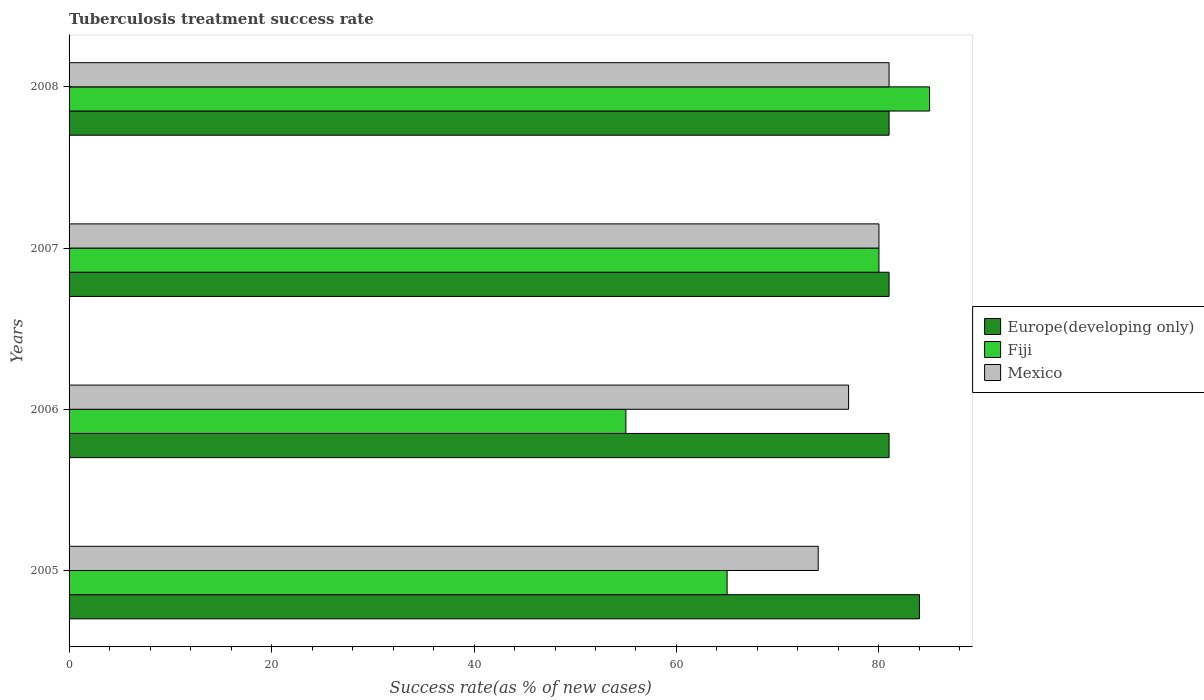How many bars are there on the 2nd tick from the bottom?
Your response must be concise. 3. What is the label of the 2nd group of bars from the top?
Offer a terse response. 2007. What is the tuberculosis treatment success rate in Fiji in 2006?
Ensure brevity in your answer.  55. Across all years, what is the maximum tuberculosis treatment success rate in Fiji?
Provide a short and direct response. 85. Across all years, what is the minimum tuberculosis treatment success rate in Mexico?
Offer a very short reply. 74. What is the total tuberculosis treatment success rate in Europe(developing only) in the graph?
Your answer should be very brief. 327. What is the difference between the tuberculosis treatment success rate in Fiji in 2005 and that in 2008?
Your response must be concise. -20. What is the average tuberculosis treatment success rate in Mexico per year?
Give a very brief answer. 78. In how many years, is the tuberculosis treatment success rate in Fiji greater than 64 %?
Offer a very short reply. 3. What is the ratio of the tuberculosis treatment success rate in Mexico in 2005 to that in 2008?
Give a very brief answer. 0.91. In how many years, is the tuberculosis treatment success rate in Fiji greater than the average tuberculosis treatment success rate in Fiji taken over all years?
Provide a succinct answer. 2. Is the sum of the tuberculosis treatment success rate in Mexico in 2007 and 2008 greater than the maximum tuberculosis treatment success rate in Europe(developing only) across all years?
Keep it short and to the point. Yes. What does the 2nd bar from the top in 2005 represents?
Offer a terse response. Fiji. Is it the case that in every year, the sum of the tuberculosis treatment success rate in Mexico and tuberculosis treatment success rate in Europe(developing only) is greater than the tuberculosis treatment success rate in Fiji?
Give a very brief answer. Yes. How many bars are there?
Provide a short and direct response. 12. Are the values on the major ticks of X-axis written in scientific E-notation?
Offer a very short reply. No. Where does the legend appear in the graph?
Provide a short and direct response. Center right. How are the legend labels stacked?
Your answer should be very brief. Vertical. What is the title of the graph?
Keep it short and to the point. Tuberculosis treatment success rate. What is the label or title of the X-axis?
Make the answer very short. Success rate(as % of new cases). What is the label or title of the Y-axis?
Your answer should be very brief. Years. What is the Success rate(as % of new cases) in Fiji in 2005?
Your answer should be very brief. 65. What is the Success rate(as % of new cases) in Mexico in 2005?
Ensure brevity in your answer.  74. What is the Success rate(as % of new cases) of Europe(developing only) in 2007?
Your response must be concise. 81. What is the Success rate(as % of new cases) of Fiji in 2007?
Offer a terse response. 80. What is the Success rate(as % of new cases) of Fiji in 2008?
Provide a succinct answer. 85. What is the Success rate(as % of new cases) of Mexico in 2008?
Give a very brief answer. 81. What is the total Success rate(as % of new cases) of Europe(developing only) in the graph?
Ensure brevity in your answer.  327. What is the total Success rate(as % of new cases) of Fiji in the graph?
Offer a very short reply. 285. What is the total Success rate(as % of new cases) of Mexico in the graph?
Your answer should be compact. 312. What is the difference between the Success rate(as % of new cases) of Europe(developing only) in 2005 and that in 2006?
Your response must be concise. 3. What is the difference between the Success rate(as % of new cases) in Fiji in 2005 and that in 2006?
Provide a short and direct response. 10. What is the difference between the Success rate(as % of new cases) of Mexico in 2005 and that in 2006?
Your response must be concise. -3. What is the difference between the Success rate(as % of new cases) in Fiji in 2005 and that in 2007?
Provide a short and direct response. -15. What is the difference between the Success rate(as % of new cases) of Mexico in 2005 and that in 2007?
Your answer should be compact. -6. What is the difference between the Success rate(as % of new cases) of Mexico in 2005 and that in 2008?
Keep it short and to the point. -7. What is the difference between the Success rate(as % of new cases) in Fiji in 2006 and that in 2007?
Ensure brevity in your answer.  -25. What is the difference between the Success rate(as % of new cases) in Europe(developing only) in 2006 and that in 2008?
Offer a terse response. 0. What is the difference between the Success rate(as % of new cases) of Fiji in 2006 and that in 2008?
Ensure brevity in your answer.  -30. What is the difference between the Success rate(as % of new cases) in Mexico in 2006 and that in 2008?
Your answer should be very brief. -4. What is the difference between the Success rate(as % of new cases) of Europe(developing only) in 2007 and that in 2008?
Your answer should be compact. 0. What is the difference between the Success rate(as % of new cases) of Fiji in 2007 and that in 2008?
Ensure brevity in your answer.  -5. What is the difference between the Success rate(as % of new cases) in Mexico in 2007 and that in 2008?
Keep it short and to the point. -1. What is the difference between the Success rate(as % of new cases) of Europe(developing only) in 2005 and the Success rate(as % of new cases) of Mexico in 2006?
Provide a succinct answer. 7. What is the difference between the Success rate(as % of new cases) in Europe(developing only) in 2005 and the Success rate(as % of new cases) in Fiji in 2007?
Offer a very short reply. 4. What is the difference between the Success rate(as % of new cases) of Europe(developing only) in 2005 and the Success rate(as % of new cases) of Mexico in 2007?
Give a very brief answer. 4. What is the difference between the Success rate(as % of new cases) of Europe(developing only) in 2006 and the Success rate(as % of new cases) of Fiji in 2007?
Offer a very short reply. 1. What is the difference between the Success rate(as % of new cases) of Fiji in 2006 and the Success rate(as % of new cases) of Mexico in 2007?
Offer a very short reply. -25. What is the difference between the Success rate(as % of new cases) in Europe(developing only) in 2006 and the Success rate(as % of new cases) in Fiji in 2008?
Your answer should be very brief. -4. What is the difference between the Success rate(as % of new cases) in Europe(developing only) in 2007 and the Success rate(as % of new cases) in Mexico in 2008?
Provide a succinct answer. 0. What is the difference between the Success rate(as % of new cases) of Fiji in 2007 and the Success rate(as % of new cases) of Mexico in 2008?
Your answer should be very brief. -1. What is the average Success rate(as % of new cases) in Europe(developing only) per year?
Offer a terse response. 81.75. What is the average Success rate(as % of new cases) of Fiji per year?
Provide a succinct answer. 71.25. What is the average Success rate(as % of new cases) of Mexico per year?
Your answer should be compact. 78. In the year 2005, what is the difference between the Success rate(as % of new cases) in Europe(developing only) and Success rate(as % of new cases) in Fiji?
Provide a short and direct response. 19. In the year 2005, what is the difference between the Success rate(as % of new cases) in Europe(developing only) and Success rate(as % of new cases) in Mexico?
Make the answer very short. 10. In the year 2007, what is the difference between the Success rate(as % of new cases) in Europe(developing only) and Success rate(as % of new cases) in Fiji?
Provide a short and direct response. 1. In the year 2007, what is the difference between the Success rate(as % of new cases) of Fiji and Success rate(as % of new cases) of Mexico?
Your response must be concise. 0. In the year 2008, what is the difference between the Success rate(as % of new cases) of Europe(developing only) and Success rate(as % of new cases) of Fiji?
Offer a very short reply. -4. In the year 2008, what is the difference between the Success rate(as % of new cases) of Europe(developing only) and Success rate(as % of new cases) of Mexico?
Your answer should be compact. 0. What is the ratio of the Success rate(as % of new cases) in Fiji in 2005 to that in 2006?
Make the answer very short. 1.18. What is the ratio of the Success rate(as % of new cases) of Europe(developing only) in 2005 to that in 2007?
Keep it short and to the point. 1.04. What is the ratio of the Success rate(as % of new cases) in Fiji in 2005 to that in 2007?
Provide a succinct answer. 0.81. What is the ratio of the Success rate(as % of new cases) of Mexico in 2005 to that in 2007?
Your answer should be compact. 0.93. What is the ratio of the Success rate(as % of new cases) in Fiji in 2005 to that in 2008?
Ensure brevity in your answer.  0.76. What is the ratio of the Success rate(as % of new cases) of Mexico in 2005 to that in 2008?
Keep it short and to the point. 0.91. What is the ratio of the Success rate(as % of new cases) in Europe(developing only) in 2006 to that in 2007?
Your answer should be compact. 1. What is the ratio of the Success rate(as % of new cases) in Fiji in 2006 to that in 2007?
Your answer should be compact. 0.69. What is the ratio of the Success rate(as % of new cases) of Mexico in 2006 to that in 2007?
Provide a short and direct response. 0.96. What is the ratio of the Success rate(as % of new cases) of Fiji in 2006 to that in 2008?
Offer a terse response. 0.65. What is the ratio of the Success rate(as % of new cases) of Mexico in 2006 to that in 2008?
Ensure brevity in your answer.  0.95. What is the difference between the highest and the second highest Success rate(as % of new cases) of Europe(developing only)?
Give a very brief answer. 3. What is the difference between the highest and the second highest Success rate(as % of new cases) in Fiji?
Give a very brief answer. 5. What is the difference between the highest and the lowest Success rate(as % of new cases) of Fiji?
Give a very brief answer. 30. What is the difference between the highest and the lowest Success rate(as % of new cases) of Mexico?
Provide a succinct answer. 7. 